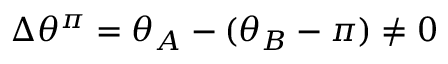Convert formula to latex. <formula><loc_0><loc_0><loc_500><loc_500>\Delta \theta ^ { \pi } = \theta _ { A } - ( \theta _ { B } - \pi ) \neq 0</formula> 